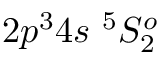Convert formula to latex. <formula><loc_0><loc_0><loc_500><loc_500>{ 2 p ^ { 3 } 4 s ^ { 5 } S _ { 2 } ^ { o } }</formula> 